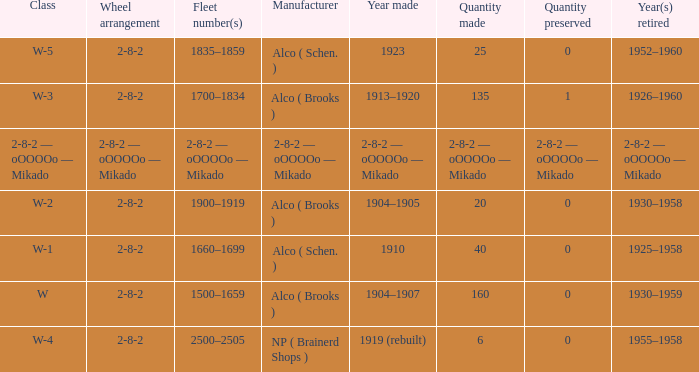Which locomotive class with a 2-8-2 wheel configuration has 25 units produced? W-5. 